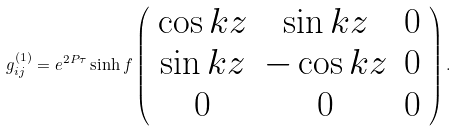<formula> <loc_0><loc_0><loc_500><loc_500>g ^ { ( 1 ) } _ { i j } = e ^ { 2 P \tau } \sinh f \left ( \begin{array} { c c c } \cos k z & \sin k z & 0 \\ \sin k z & - \cos k z & 0 \\ 0 & 0 & 0 \end{array} \right ) .</formula> 